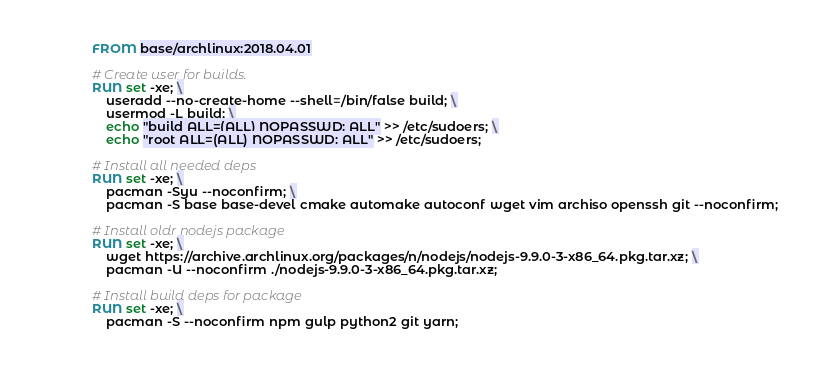<code> <loc_0><loc_0><loc_500><loc_500><_Dockerfile_>FROM base/archlinux:2018.04.01

# Create user for builds.
RUN set -xe; \
    useradd --no-create-home --shell=/bin/false build; \
    usermod -L build; \
    echo "build ALL=(ALL) NOPASSWD: ALL" >> /etc/sudoers; \
    echo "root ALL=(ALL) NOPASSWD: ALL" >> /etc/sudoers;

# Install all needed deps
RUN set -xe; \
    pacman -Syu --noconfirm; \
    pacman -S base base-devel cmake automake autoconf wget vim archiso openssh git --noconfirm;

# Install oldr nodejs package
RUN set -xe; \
    wget https://archive.archlinux.org/packages/n/nodejs/nodejs-9.9.0-3-x86_64.pkg.tar.xz; \
    pacman -U --noconfirm ./nodejs-9.9.0-3-x86_64.pkg.tar.xz;

# Install build deps for package
RUN set -xe; \
    pacman -S --noconfirm npm gulp python2 git yarn;
</code> 